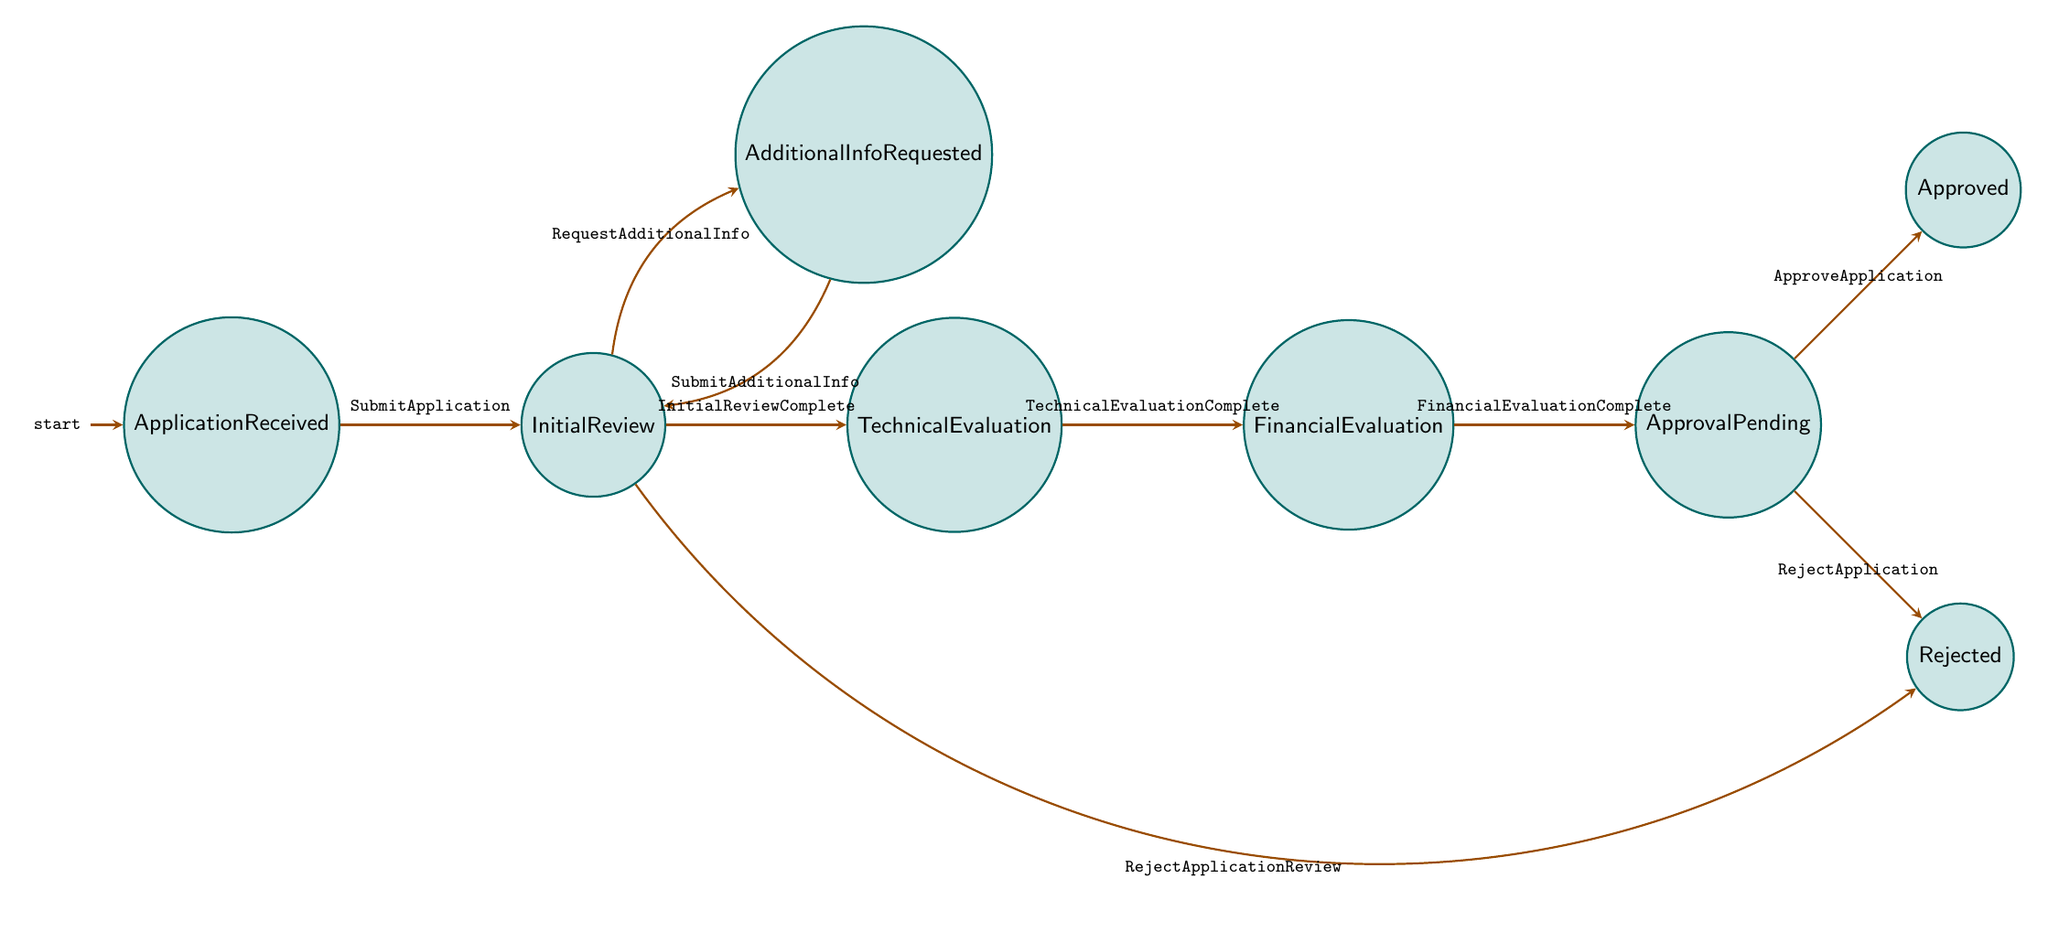What is the initial state of the biofuel subsidy workflow? The initial state is labeled as "ApplicationReceived," indicating that this is where the process starts after the application is submitted.
Answer: ApplicationReceived How many total states are present in the workflow? By counting the states listed in the diagram, we see that there are eight distinct states involved in the process.
Answer: Eight What transition occurs after the "InitialReview" state is completed? Upon completion of the initial review, the transition labeled "InitialReviewComplete" leads the workflow to the "TechnicalEvaluation" state.
Answer: TechnicalEvaluation Which state represents the decision-making point for application approval? The "ApprovalPending" state is where the final decision regarding the application's approval or rejection is made, based on previous evaluations.
Answer: ApprovalPending What happens if additional information is requested during the application review? If additional information is needed, the workflow transitions to the "AdditionalInformationRequested" state, where the applicant is asked to provide more documentation.
Answer: AdditionalInformationRequested What are the possible outcomes after the "ApprovalPending" state? There are two possible outcomes: the application can either progress to the "Approved" state if approved, or move to the "Rejected" state if rejected, as indicated by the corresponding transitions.
Answer: Approved or Rejected If an application is rejected after the initial review, which state does it go to? If the application is rejected during the initial review phase, it transitions directly to the "Rejected" state, according to the "RejectApplicationReview" transition.
Answer: Rejected What step follows after the "FinancialEvaluation" is complete? After the financial evaluation is complete, the next step is the state labeled "ApprovalPending," where the application awaits a final decision.
Answer: ApprovalPending How is additional documentation submitted after a request? After additional documentation is requested, the applicant submits the required information, leading back to the "InitialReview" state to reassess the application.
Answer: InitialReview 